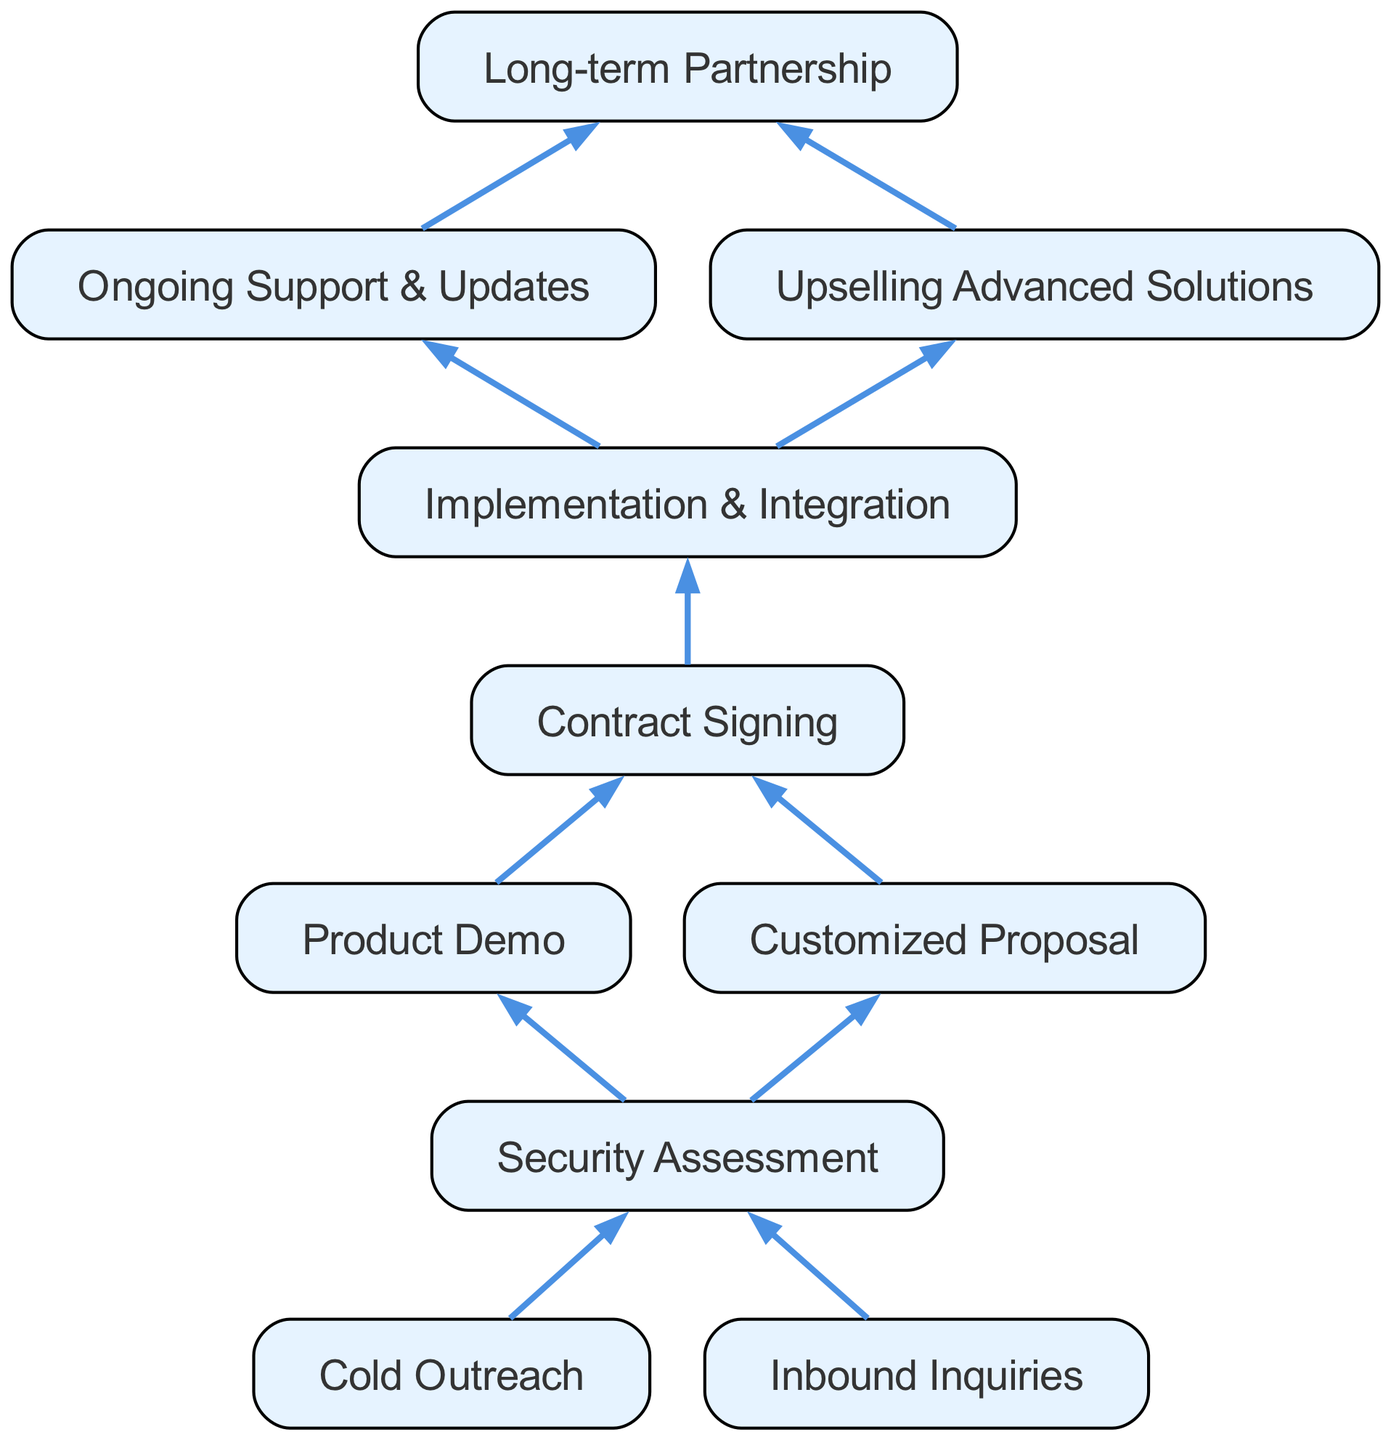What is the final node in the funnel? The final node is "Long-term Partnership," which is at the top of the diagram as it represents the end goal of the customer acquisition process.
Answer: Long-term Partnership How many child nodes does "Implementation & Integration" have? "Implementation & Integration" has one child node, which is "Contract Signing," indicating the next step in the process after implementation.
Answer: 1 What are the two main activities after "Contract Signing"? The two main activities following "Contract Signing" are "Product Demo" and "Customized Proposal." These are the subsequent steps in customer engagement after signing the contract.
Answer: Product Demo, Customized Proposal Which node comes after "Security Assessment"? After "Security Assessment," the next nodes are "Cold Outreach" and "Inbound Inquiries." Since this is a bottom-up chart, these represent the initial contact methods before moving up the funnel.
Answer: Cold Outreach, Inbound Inquiries What is the relationship between "Upselling Advanced Solutions" and "Ongoing Support & Updates"? "Upselling Advanced Solutions" and "Ongoing Support & Updates" are sibling nodes branching from "Long-term Partnership," indicating they are both outcomes of a successful partnership.
Answer: Sibling nodes What is the total number of nodes in the diagram? The total number of nodes includes all the unique elements listed, from "Long-term Partnership" down to "Cold Outreach" and "Inbound Inquiries." Counting them yields a total of ten nodes.
Answer: 10 Which node is the starting point of the acquisition funnel? The starting point of the acquisition funnel is the node "Cold Outreach," as it represents the first step in the customer acquisition process.
Answer: Cold Outreach How many nodes lead directly to "Implementation & Integration"? Only one node leads directly to "Implementation & Integration," which is "Ongoing Support & Updates," indicating the necessary steps prior to implementation.
Answer: 1 What are the two methods of initial contact in this funnel? The two methods of initial contact in the funnel are "Cold Outreach" and "Inbound Inquiries," representing how potential customers first engage with our services.
Answer: Cold Outreach, Inbound Inquiries 